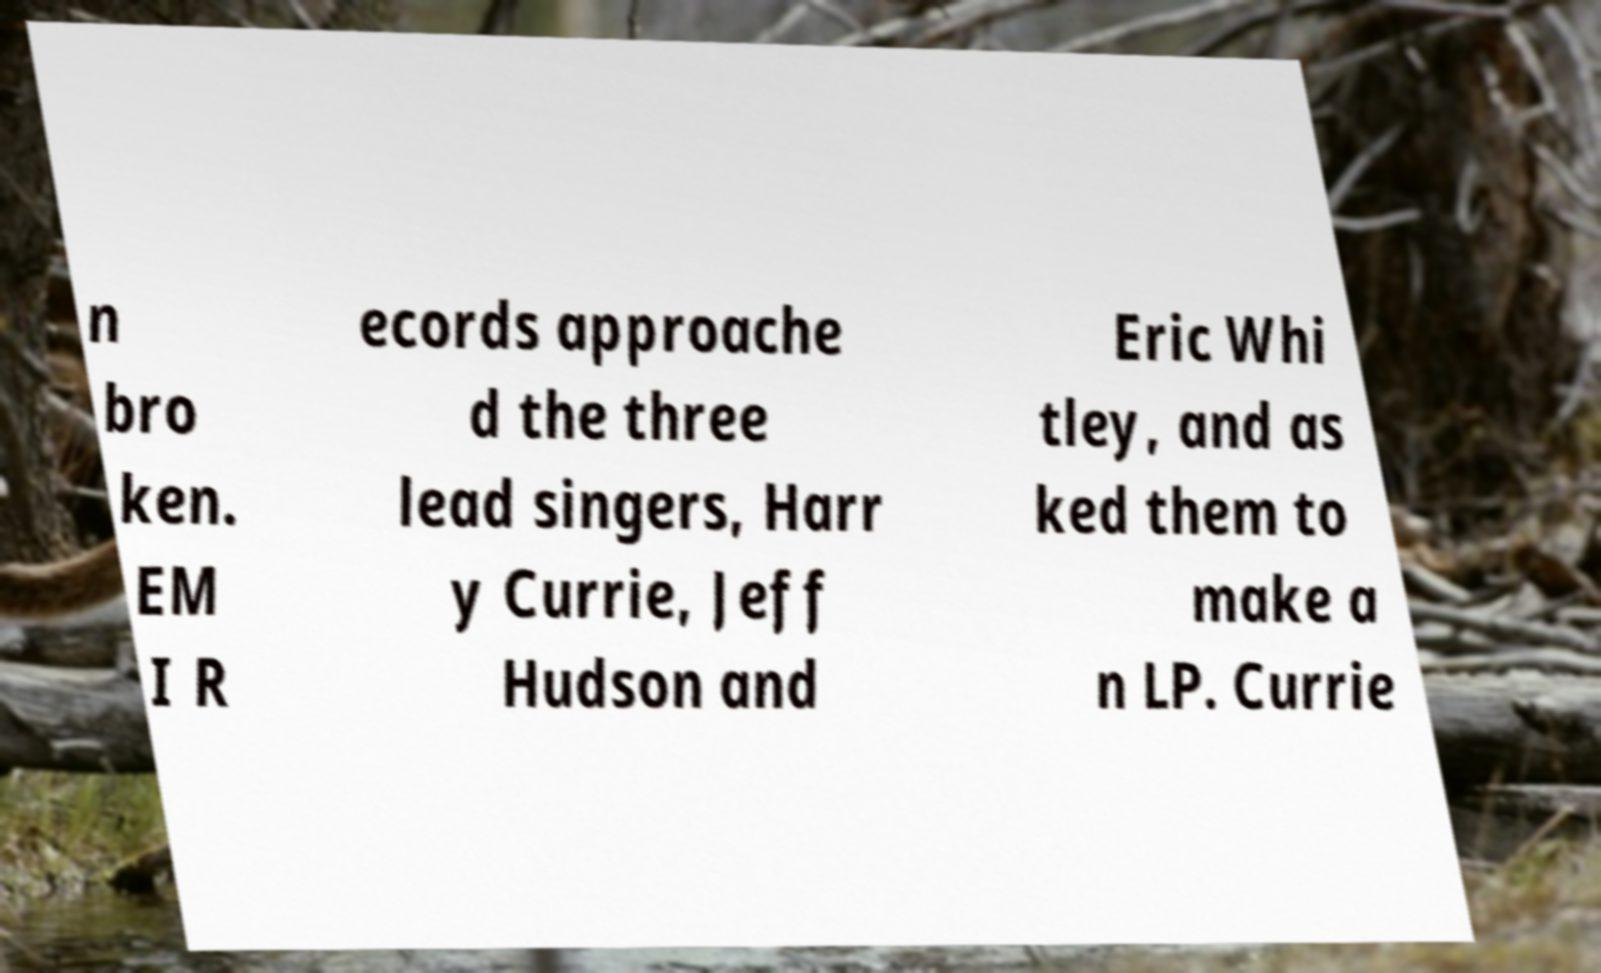Can you read and provide the text displayed in the image?This photo seems to have some interesting text. Can you extract and type it out for me? n bro ken. EM I R ecords approache d the three lead singers, Harr y Currie, Jeff Hudson and Eric Whi tley, and as ked them to make a n LP. Currie 